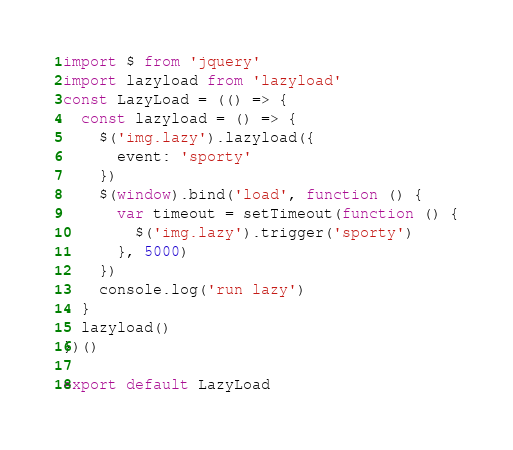Convert code to text. <code><loc_0><loc_0><loc_500><loc_500><_JavaScript_>import $ from 'jquery'
import lazyload from 'lazyload'
const LazyLoad = (() => {
  const lazyload = () => {
    $('img.lazy').lazyload({
      event: 'sporty'
    })
    $(window).bind('load', function () {
      var timeout = setTimeout(function () {
        $('img.lazy').trigger('sporty')
      }, 5000)
    })
    console.log('run lazy')
  }
  lazyload()
})()

export default LazyLoad
</code> 